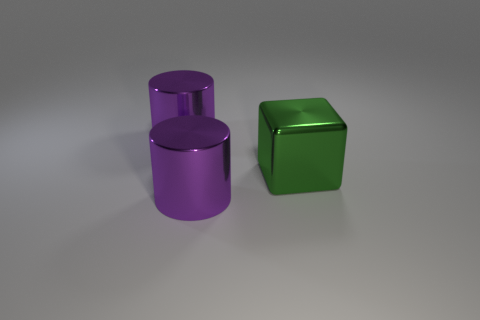Does the object that is in front of the large green metallic cube have the same color as the large cylinder that is behind the green metal object?
Provide a short and direct response. Yes. There is a big cube; what number of large things are to the right of it?
Keep it short and to the point. 0. Are there any large cubes that have the same material as the large green thing?
Offer a terse response. No. What size is the block?
Keep it short and to the point. Large. There is a purple shiny object in front of the green metal cube; what is its shape?
Your response must be concise. Cylinder. Are there the same number of big purple metal cylinders behind the large green metal block and large purple metallic things?
Keep it short and to the point. No. What is the shape of the green thing?
Provide a succinct answer. Cube. Are there any other things that have the same color as the large block?
Give a very brief answer. No. Do the purple metal cylinder behind the green object and the cylinder that is in front of the large green cube have the same size?
Offer a very short reply. Yes. What is the shape of the purple thing on the left side of the purple thing that is in front of the large metallic block?
Keep it short and to the point. Cylinder. 